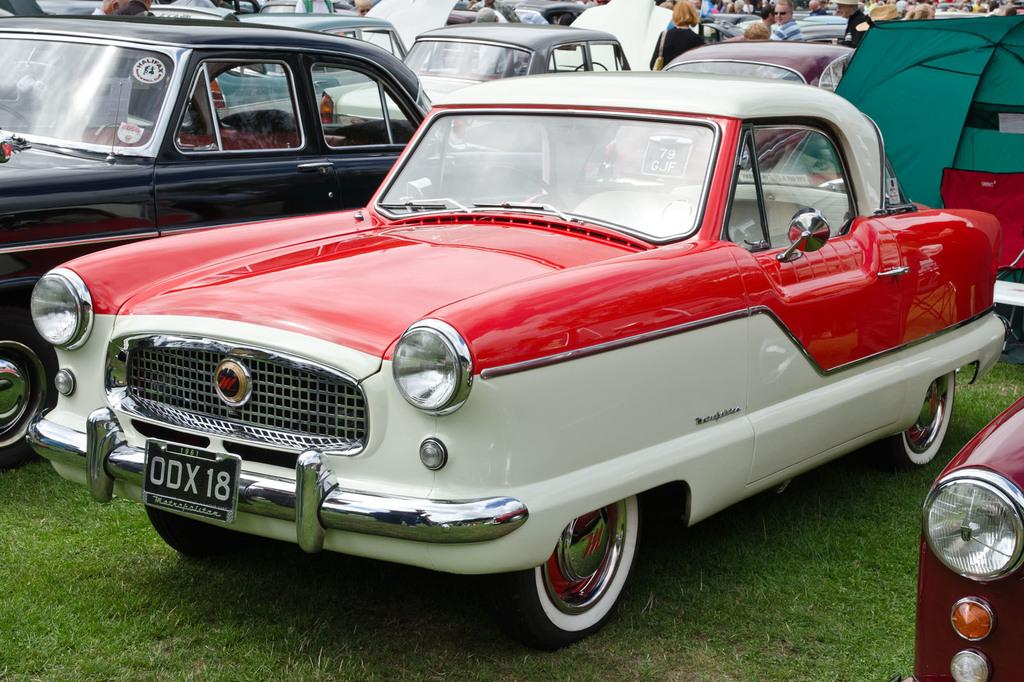What types of vehicles are present in the image? There are cars with different colors in the image. Can you describe the people in the image? There are people in the image, but their specific actions or characteristics are not mentioned in the provided facts. What type of ground surface is visible in the image? There is grass on the ground in the image. What type of space-themed scene is depicted in the image? There is no space-themed scene present in the image; it features cars, people, and grass. Are the people in the image sleeping? The provided facts do not mention whether the people in the image are sleeping or not. 